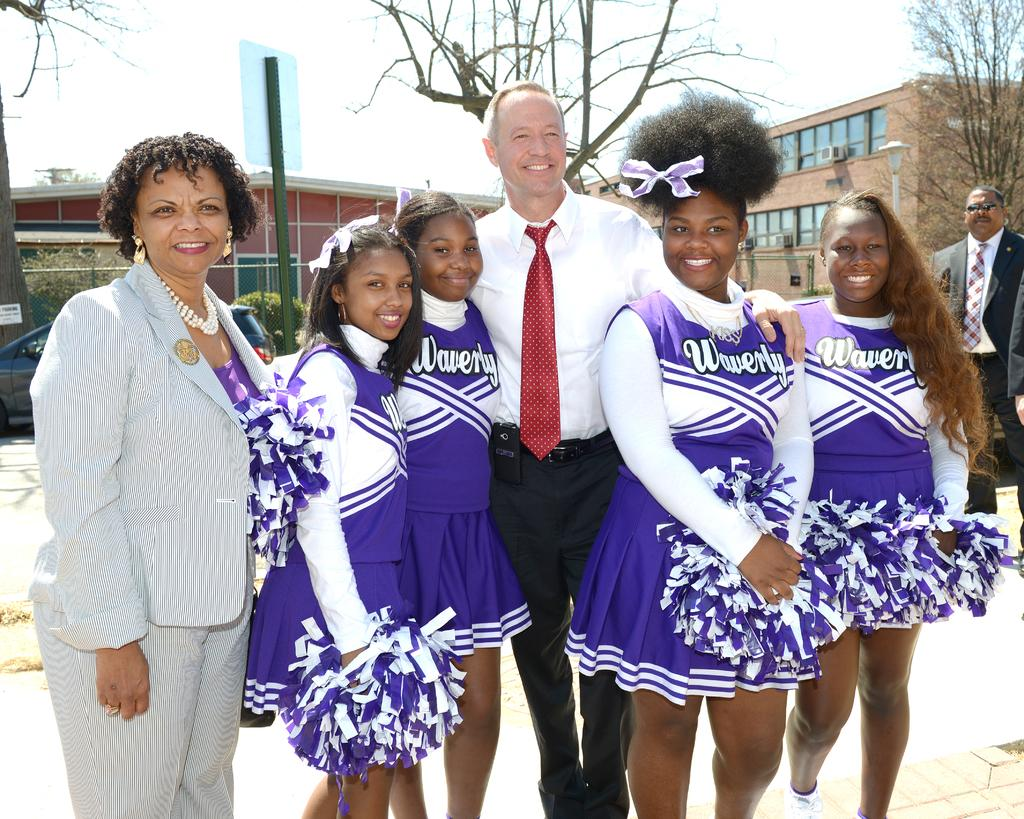<image>
Write a terse but informative summary of the picture. The four cheerleaders shown posing for a picture are from Waverley. 